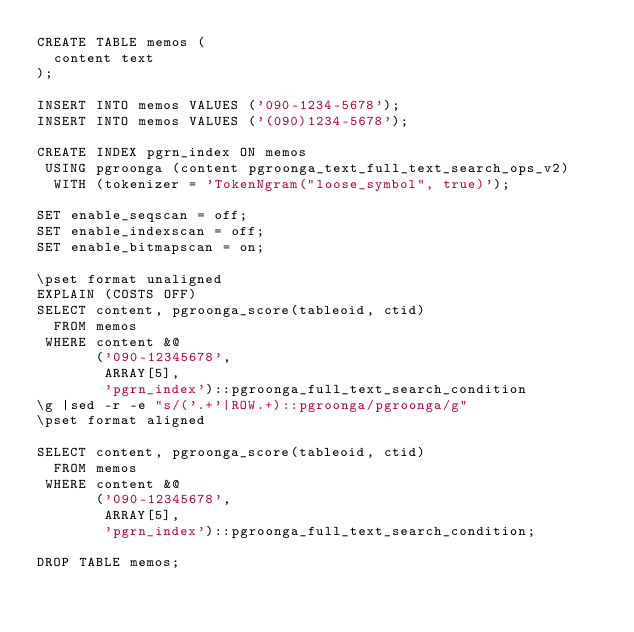<code> <loc_0><loc_0><loc_500><loc_500><_SQL_>CREATE TABLE memos (
  content text
);

INSERT INTO memos VALUES ('090-1234-5678');
INSERT INTO memos VALUES ('(090)1234-5678');

CREATE INDEX pgrn_index ON memos
 USING pgroonga (content pgroonga_text_full_text_search_ops_v2)
  WITH (tokenizer = 'TokenNgram("loose_symbol", true)');

SET enable_seqscan = off;
SET enable_indexscan = off;
SET enable_bitmapscan = on;

\pset format unaligned
EXPLAIN (COSTS OFF)
SELECT content, pgroonga_score(tableoid, ctid)
  FROM memos
 WHERE content &@
       ('090-12345678',
        ARRAY[5],
        'pgrn_index')::pgroonga_full_text_search_condition
\g |sed -r -e "s/('.+'|ROW.+)::pgroonga/pgroonga/g"
\pset format aligned

SELECT content, pgroonga_score(tableoid, ctid)
  FROM memos
 WHERE content &@
       ('090-12345678',
        ARRAY[5],
        'pgrn_index')::pgroonga_full_text_search_condition;

DROP TABLE memos;
</code> 